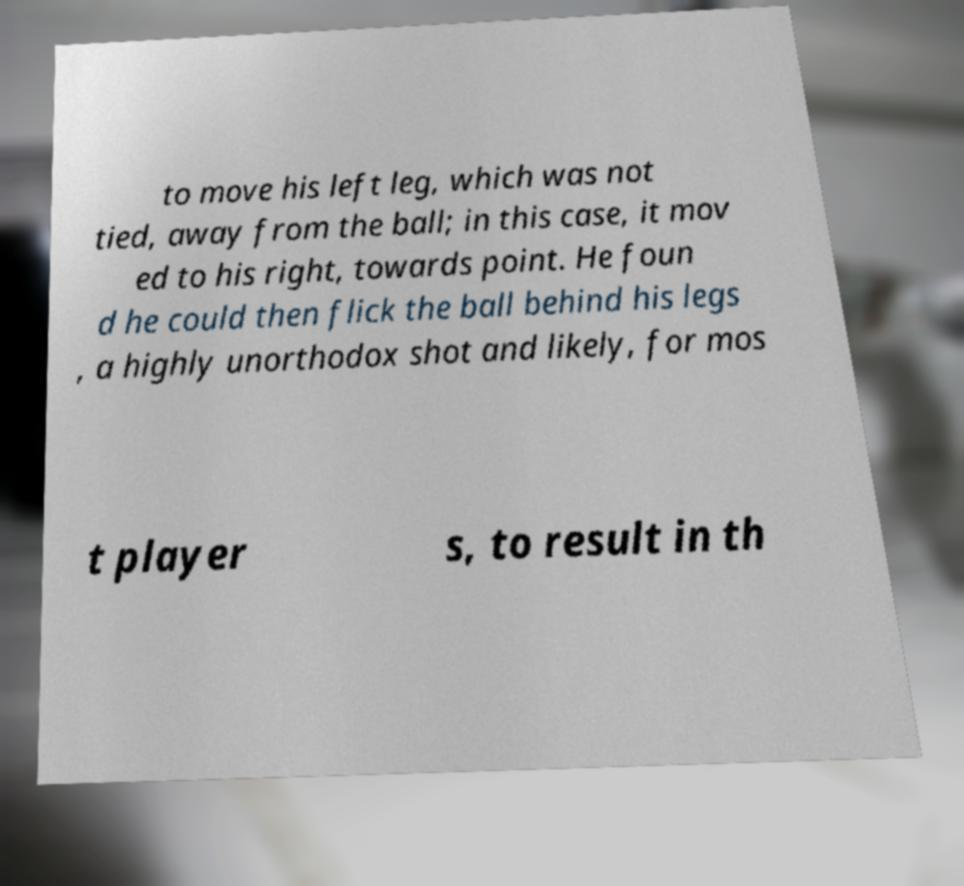Could you assist in decoding the text presented in this image and type it out clearly? to move his left leg, which was not tied, away from the ball; in this case, it mov ed to his right, towards point. He foun d he could then flick the ball behind his legs , a highly unorthodox shot and likely, for mos t player s, to result in th 